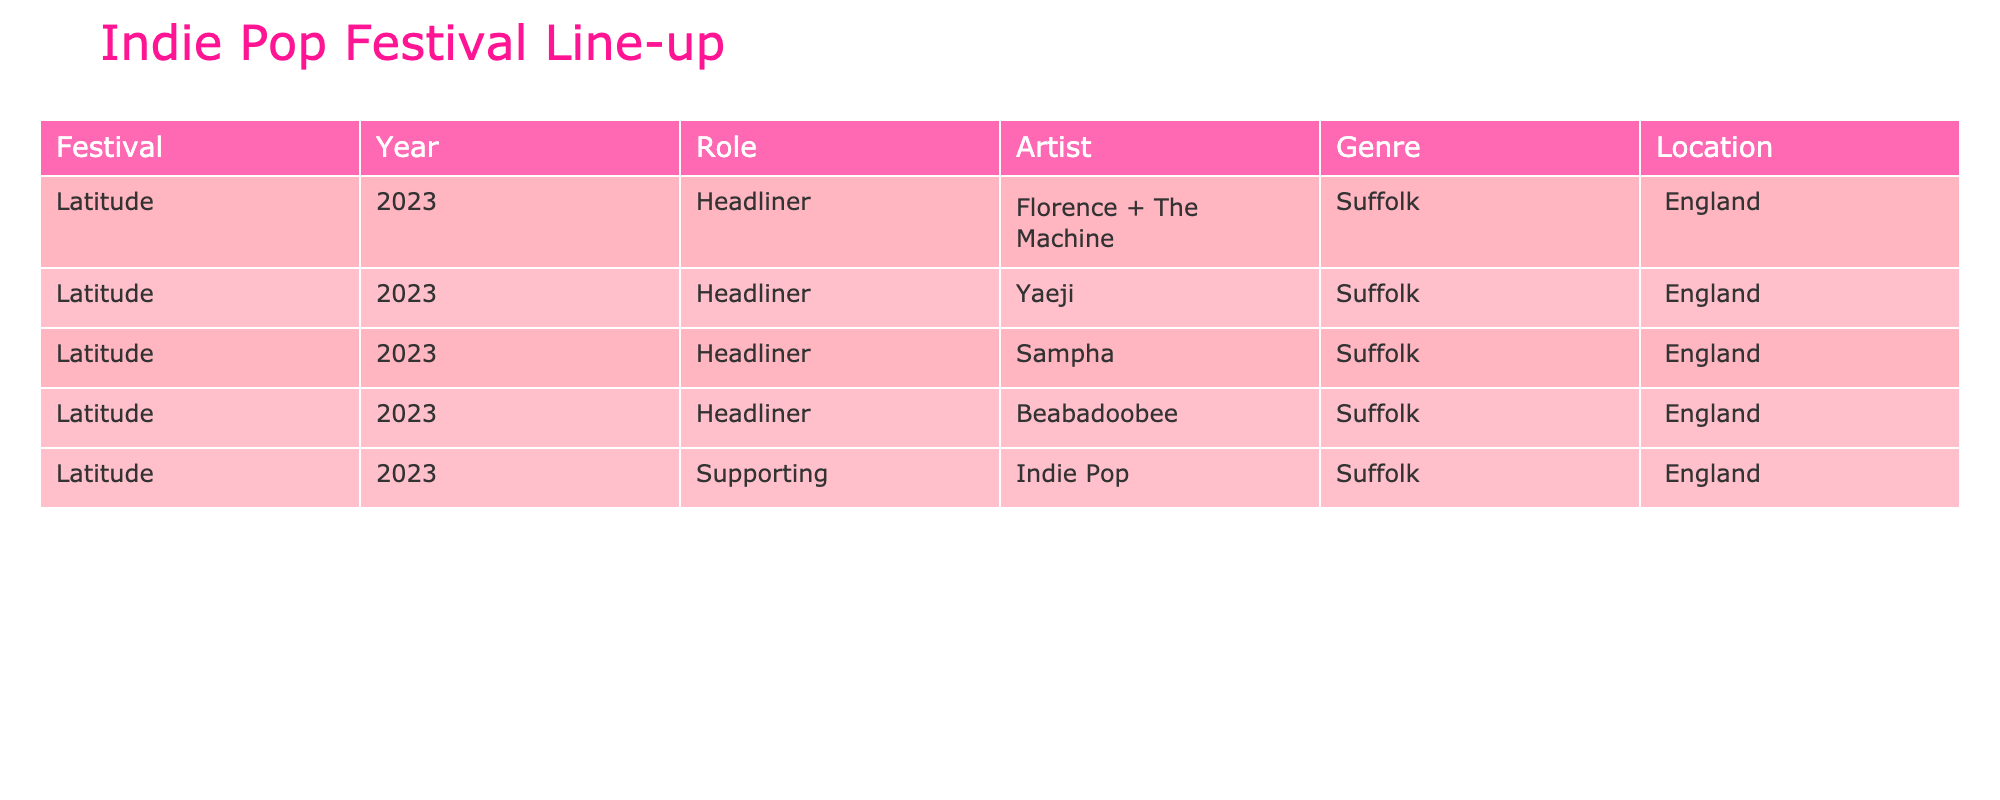What is the headliner for the Latitude festival in 2023? The table lists the headliners for the Latitude festival in 2023, which is Florence + The Machine.
Answer: Florence + The Machine How many supporting acts are listed for the Latitude festival in 2023? The table shows four supporting acts for the Latitude festival in 2023: Yaeji, Sampha, and Beabadoobee, totaling three artists.
Answer: 3 Is "Festival" one of the genres associated with the artists in the table? The genre listed for the Latitude festival in 2023 is Indie Pop, which does not match "Festival." Therefore, the answer is no.
Answer: No Which location hosted the Latitude festival in 2023? The table indicates that the Latitude festival in 2023 took place in Suffolk, England.
Answer: Suffolk, England What is the total number of artists (headliners and supporting) for the Latitude festival in 2023? The total number of artists includes one headliner (Florence + The Machine) and three supporting acts (Yaeji, Sampha, Beabadoobee), totaling four artists.
Answer: 4 Are all the artists at the Latitude festival in 2023 classified as Indie Pop? The table specifies that all listed artists are associated with the Indie Pop genre, confirming a 'yes' answer.
Answer: Yes Who among the artists has the role of supporting act at the Latitude festival in 2023? The supporting act artists listed for the Latitude festival in 2023 are Yaeji, Sampha, and Beabadoobee.
Answer: Yaeji, Sampha, Beabadoobee What is the difference in the number of headliners and supporting acts at the Latitude festival in 2023? There is 1 headliner (Florence + The Machine) and 3 supporting acts (Yaeji, Sampha, Beabadoobee). Therefore, the difference is 3 - 1 = 2.
Answer: 2 Is there any artist in the supporting acts that is also a headliner at another festival in the same year? The table does not provide information on other festivals or whether supporting acts are headliners elsewhere, so this cannot be determined.
Answer: Unable to determine What is the ratio of headliners to all artists at the Latitude festival in 2023? There is 1 headliner and a total of 4 artists (1 headliner + 3 supporting), leading to a ratio of 1:4.
Answer: 1:4 